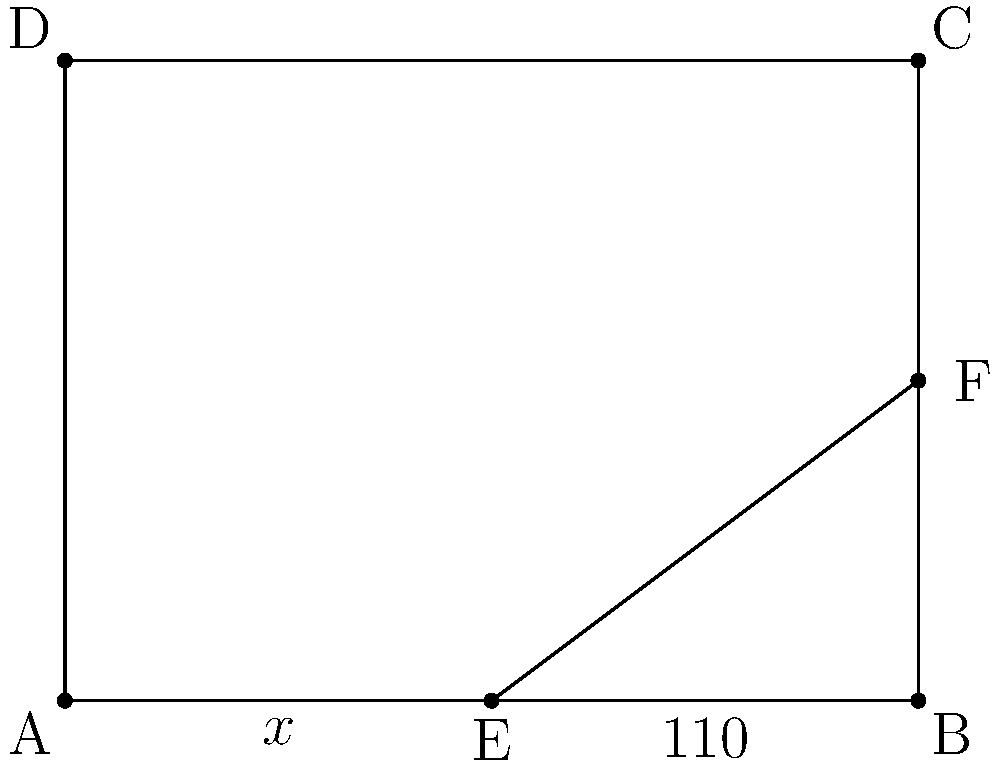In the risk assessment diagram for a virtual classroom setup, angle AEB and angle BEF form a pair of supplementary angles. If angle BEF measures 110°, what is the measure of angle AEB (represented by $x°$)? To solve this problem, we need to follow these steps:

1. Recall the definition of supplementary angles: Two angles are supplementary if their sum is 180°.

2. In this case, angle AEB and angle BEF are supplementary, so:
   $x° + 110° = 180°$

3. To find $x$, we need to solve this equation:
   $x° = 180° - 110°$

4. Simplify:
   $x° = 70°$

Therefore, the measure of angle AEB is 70°.
Answer: 70° 